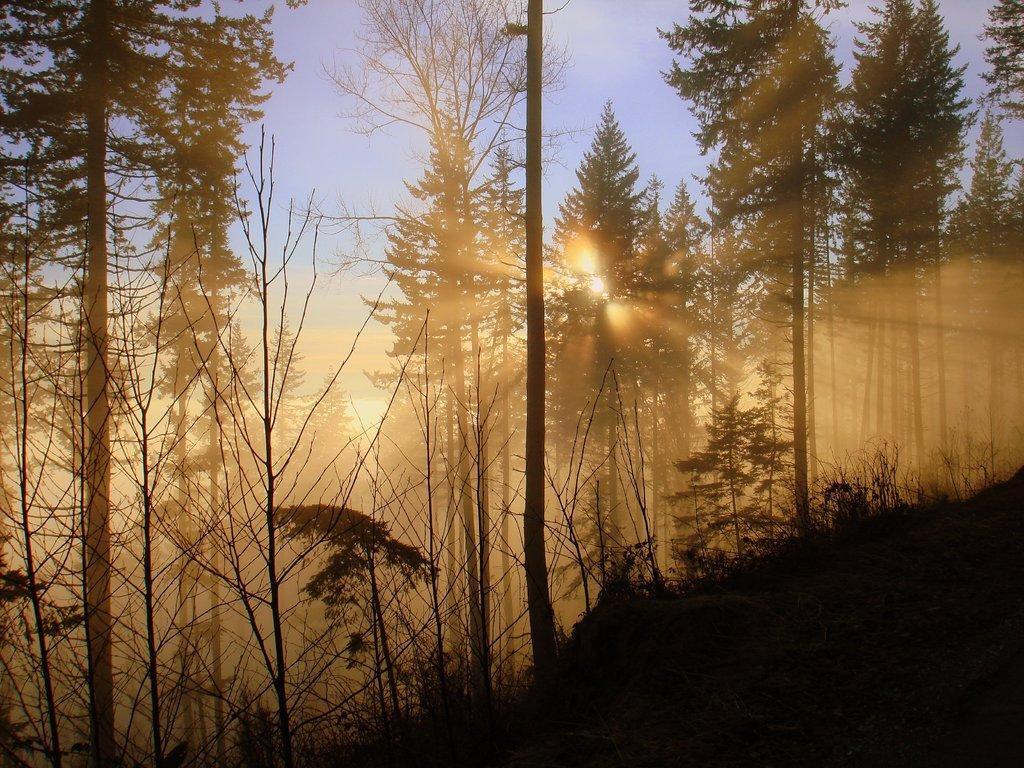What type of vegetation is present on the land in the image? There are plants and trees on the land in the image. What can be seen in the background of the image? The background of the image includes the sky. What is the condition of the sky in the image? The sun is visible in the sky. How many bears are visible in the image? There are no bears present in the image. What type of coach can be seen driving through the plants in the image? There is no coach visible in the image; it features plants, trees, and the sky. 